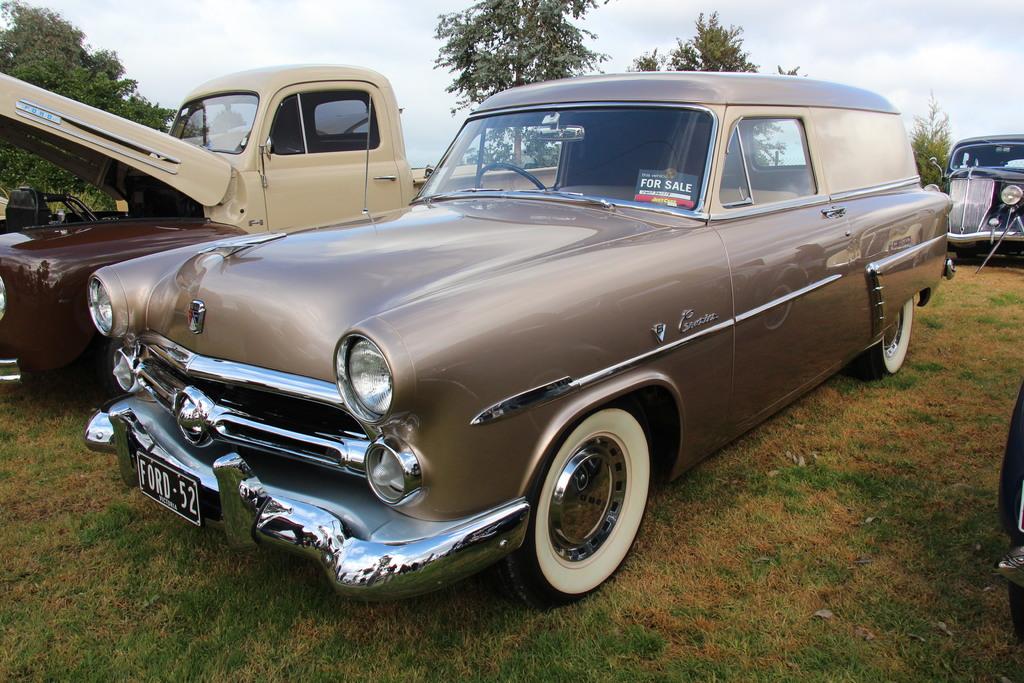What does the sign on the dash say?
Your answer should be compact. For sale. 